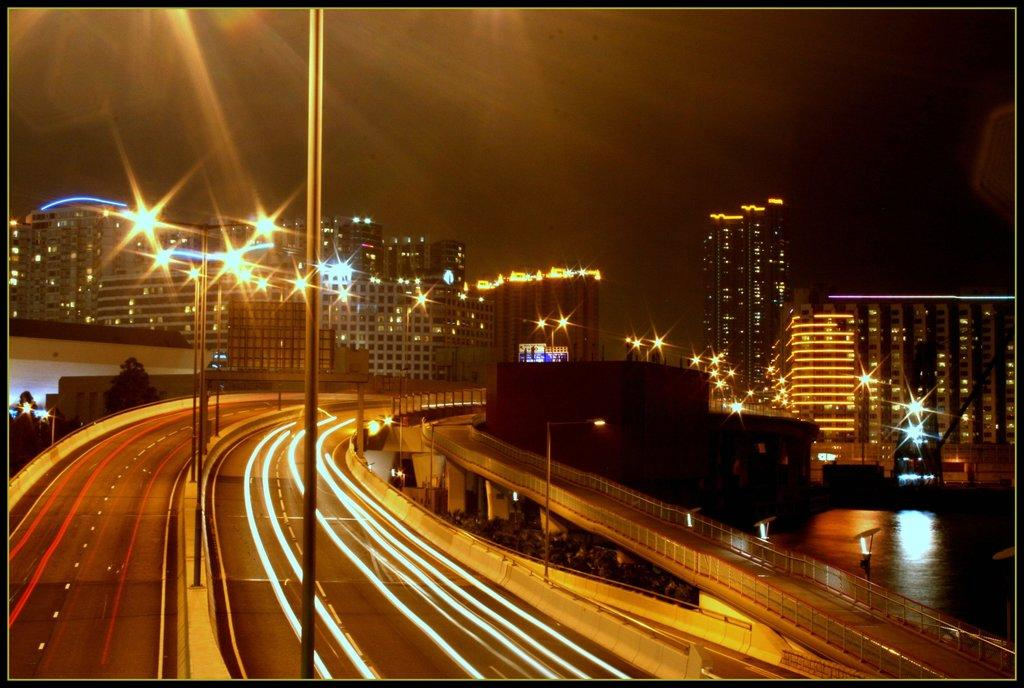What type of scene is shown in the image? The image depicts a night view of a street. What can be seen on the street? There are roads and flyovers in the image. What are the poles used for in the image? The poles are likely used for supporting lights or other infrastructure. How are the buildings in the image illuminated? There are lights and buildings with lights in the image. What is the presence of water near the street in the image? There is water near the street in the image. How many kittens can be seen playing with a key in the image? There are no kittens or keys present in the image. What type of cat is sitting on top of the flyover in the image? There are no cats present in the image. 